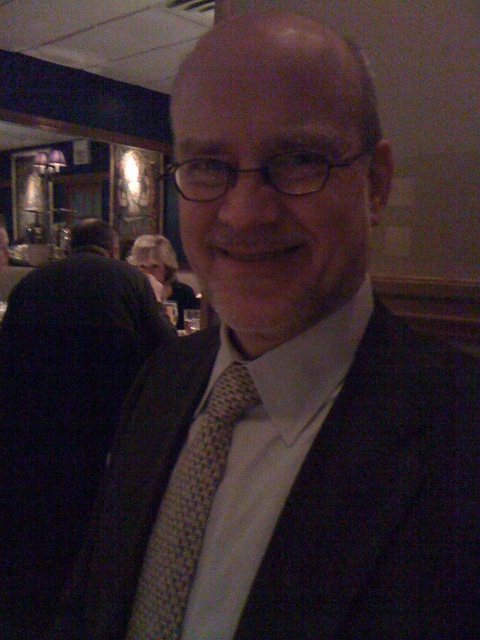Describe the objects in this image and their specific colors. I can see people in brown, black, maroon, gray, and purple tones, people in brown, black, and maroon tones, tie in brown, black, and purple tones, and people in brown, black, maroon, and gray tones in this image. 